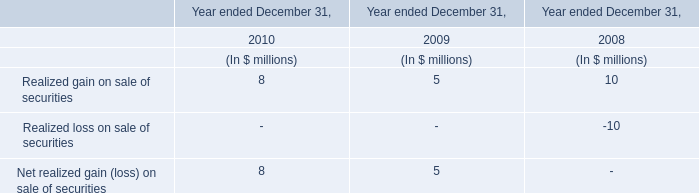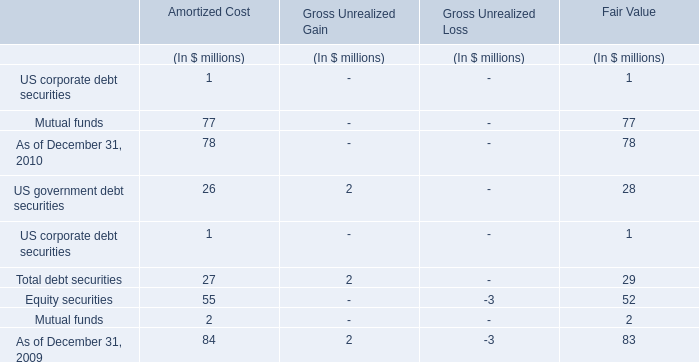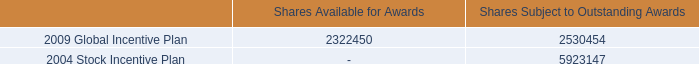in the 2009 global incentive plan what is the percent of the shares available to the shares subject to a outstanding awards 
Computations: (2322450 / (2322450 + 2530454))
Answer: 0.47857. 